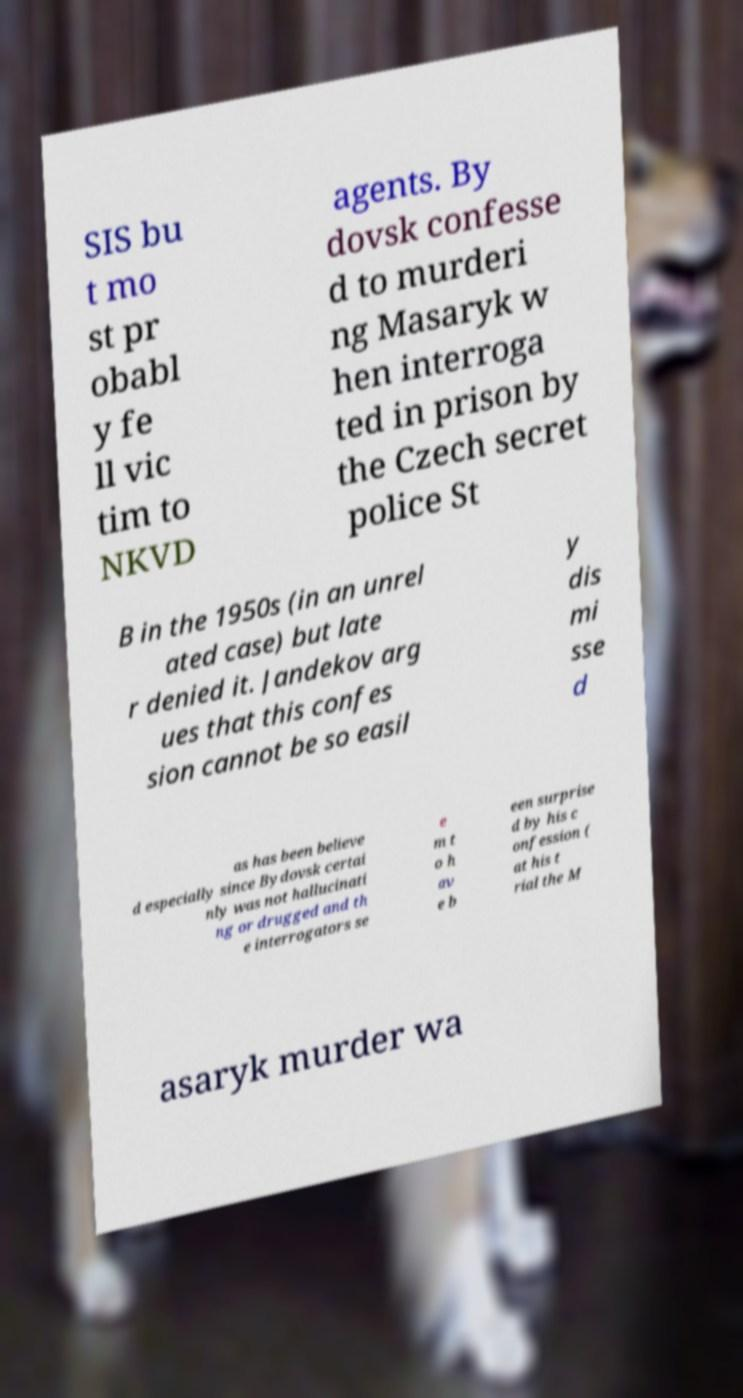Please identify and transcribe the text found in this image. SIS bu t mo st pr obabl y fe ll vic tim to NKVD agents. By dovsk confesse d to murderi ng Masaryk w hen interroga ted in prison by the Czech secret police St B in the 1950s (in an unrel ated case) but late r denied it. Jandekov arg ues that this confes sion cannot be so easil y dis mi sse d as has been believe d especially since Bydovsk certai nly was not hallucinati ng or drugged and th e interrogators se e m t o h av e b een surprise d by his c onfession ( at his t rial the M asaryk murder wa 